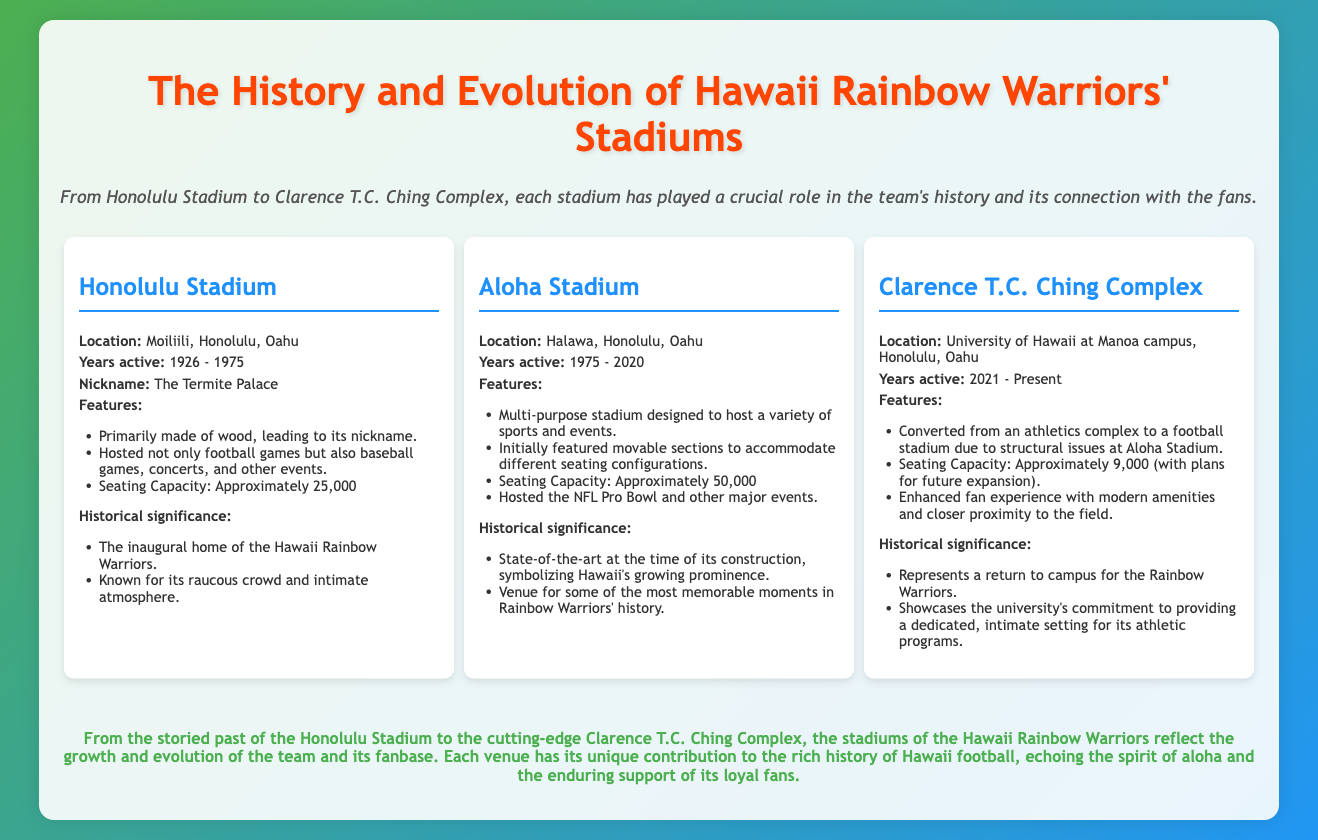what was the active period of Honolulu Stadium? The document states that Honolulu Stadium was active from 1926 to 1975.
Answer: 1926 - 1975 what is the seating capacity of Aloha Stadium? According to the document, Aloha Stadium had a seating capacity of approximately 50,000.
Answer: approximately 50,000 what is the nickname of Honolulu Stadium? The document provides the nickname for Honolulu Stadium as "The Termite Palace."
Answer: The Termite Palace which stadium is currently being used by the Hawaii Rainbow Warriors? The document mentions that the Clarence T.C. Ching Complex is active from 2021 to the present.
Answer: Clarence T.C. Ching Complex how many years was Aloha Stadium in use? By calculating the active years from 1975 to 2020, Aloha Stadium was in use for 45 years.
Answer: 45 years what features are highlighted for the Clarence T.C. Ching Complex? The document lists several features, including conversion from an athletics complex and enhanced fan experience.
Answer: Converted from an athletics complex which stadium symbolized Hawaii's growing prominence at the time of its construction? Aloha Stadium is identified in the document as the symbol of Hawaii's growing prominence.
Answer: Aloha Stadium how does the document describe the crowd atmosphere at Honolulu Stadium? The document emphasizes the raucous crowd and intimate atmosphere at Honolulu Stadium.
Answer: Raucous crowd and intimate atmosphere what was a major event hosted at Aloha Stadium? The document states that Aloha Stadium hosted the NFL Pro Bowl and other major events.
Answer: NFL Pro Bowl what does the conclusion state about the stadiums' impact on Hawaii football? The conclusion emphasizes that the stadiums reflect the growth and evolution of the team and its fan base.
Answer: Reflect the growth and evolution of the team 